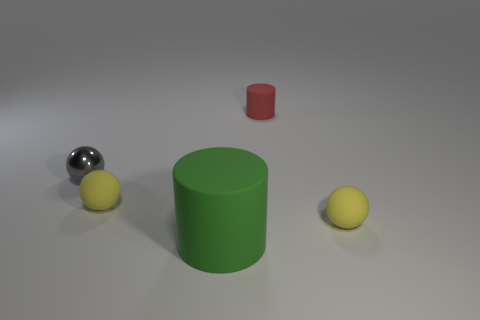Subtract all gray spheres. How many spheres are left? 2 Add 2 tiny shiny objects. How many objects exist? 7 Subtract 1 cylinders. How many cylinders are left? 1 Subtract all gray balls. How many balls are left? 2 Subtract all cylinders. How many objects are left? 3 Subtract all blue cylinders. How many yellow balls are left? 2 Subtract all large green matte cylinders. Subtract all small matte balls. How many objects are left? 2 Add 2 large matte things. How many large matte things are left? 3 Add 2 red balls. How many red balls exist? 2 Subtract 0 cyan blocks. How many objects are left? 5 